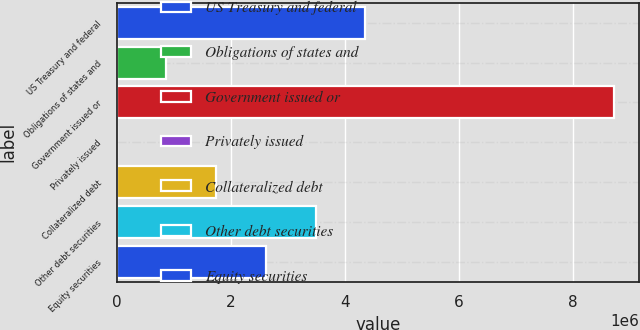Convert chart to OTSL. <chart><loc_0><loc_0><loc_500><loc_500><bar_chart><fcel>US Treasury and federal<fcel>Obligations of states and<fcel>Government issued or<fcel>Privately issued<fcel>Collateralized debt<fcel>Other debt securities<fcel>Equity securities<nl><fcel>4.36561e+06<fcel>873205<fcel>8.73112e+06<fcel>103<fcel>1.74631e+06<fcel>3.49251e+06<fcel>2.61941e+06<nl></chart> 